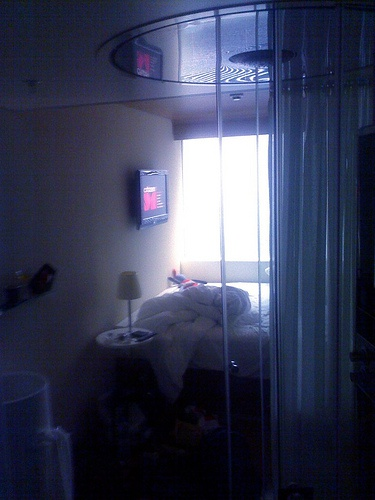Describe the objects in this image and their specific colors. I can see bed in black, navy, purple, and gray tones and tv in black, darkgray, gray, violet, and navy tones in this image. 